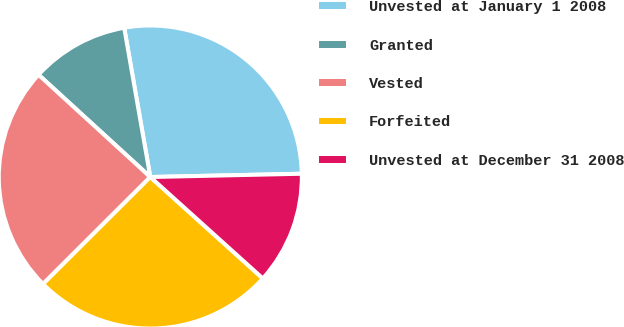Convert chart to OTSL. <chart><loc_0><loc_0><loc_500><loc_500><pie_chart><fcel>Unvested at January 1 2008<fcel>Granted<fcel>Vested<fcel>Forfeited<fcel>Unvested at December 31 2008<nl><fcel>27.41%<fcel>10.45%<fcel>24.27%<fcel>25.84%<fcel>12.02%<nl></chart> 